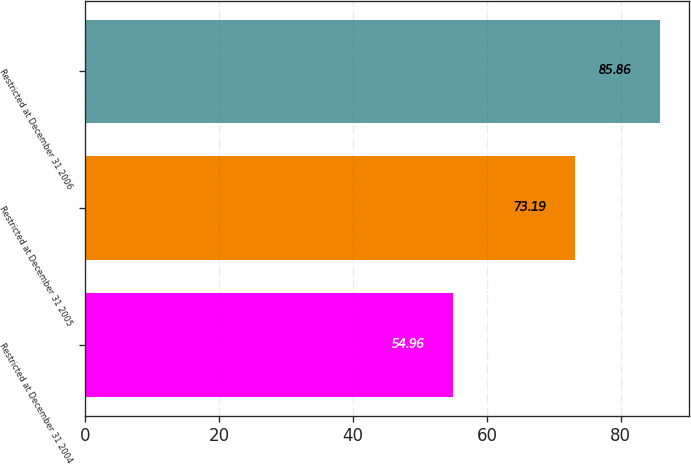<chart> <loc_0><loc_0><loc_500><loc_500><bar_chart><fcel>Restricted at December 31 2004<fcel>Restricted at December 31 2005<fcel>Restricted at December 31 2006<nl><fcel>54.96<fcel>73.19<fcel>85.86<nl></chart> 